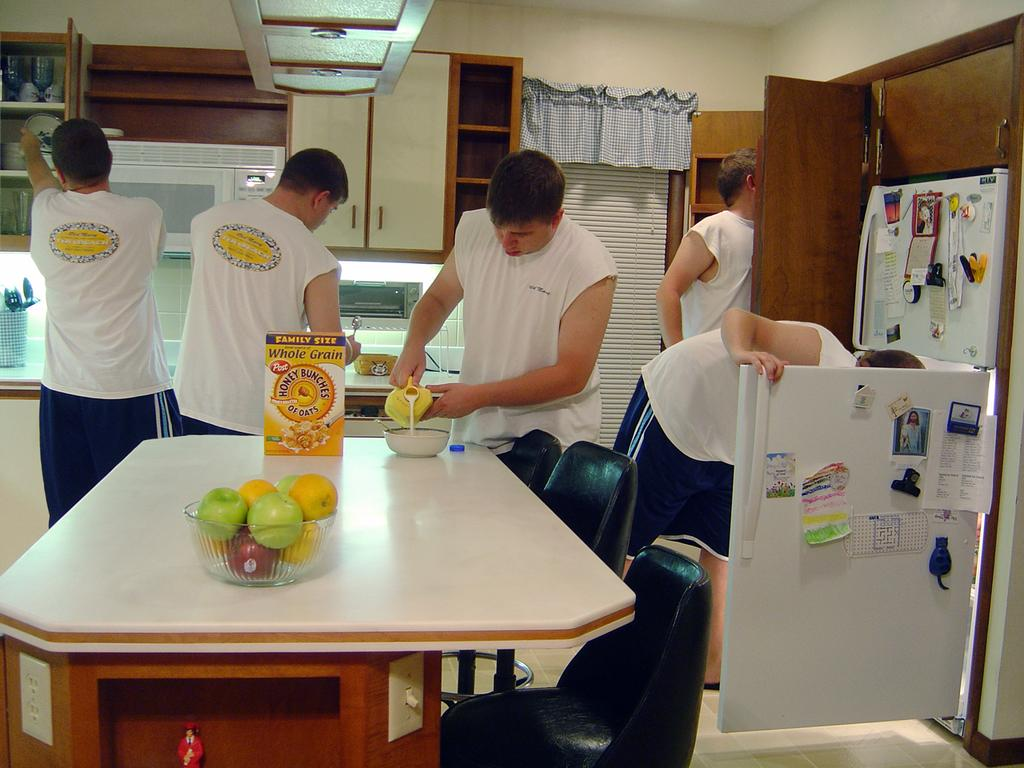<image>
Describe the image concisely. A man composited in several positions of the image preparing a bowl of Post brand honey Bunches of Oats cereal. 